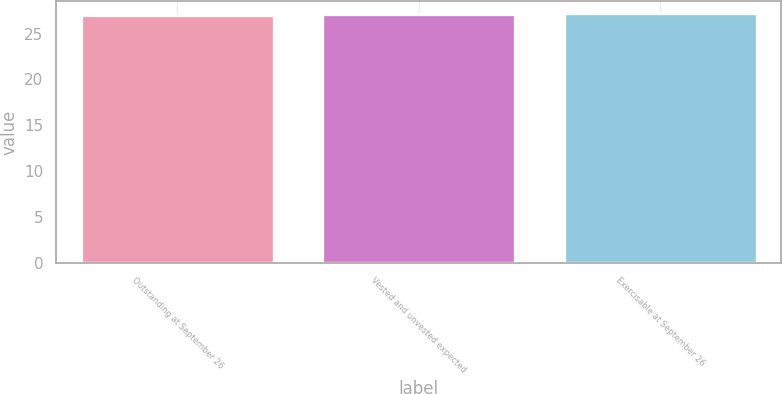<chart> <loc_0><loc_0><loc_500><loc_500><bar_chart><fcel>Outstanding at September 26<fcel>Vested and unvested expected<fcel>Exercisable at September 26<nl><fcel>27<fcel>27.1<fcel>27.2<nl></chart> 